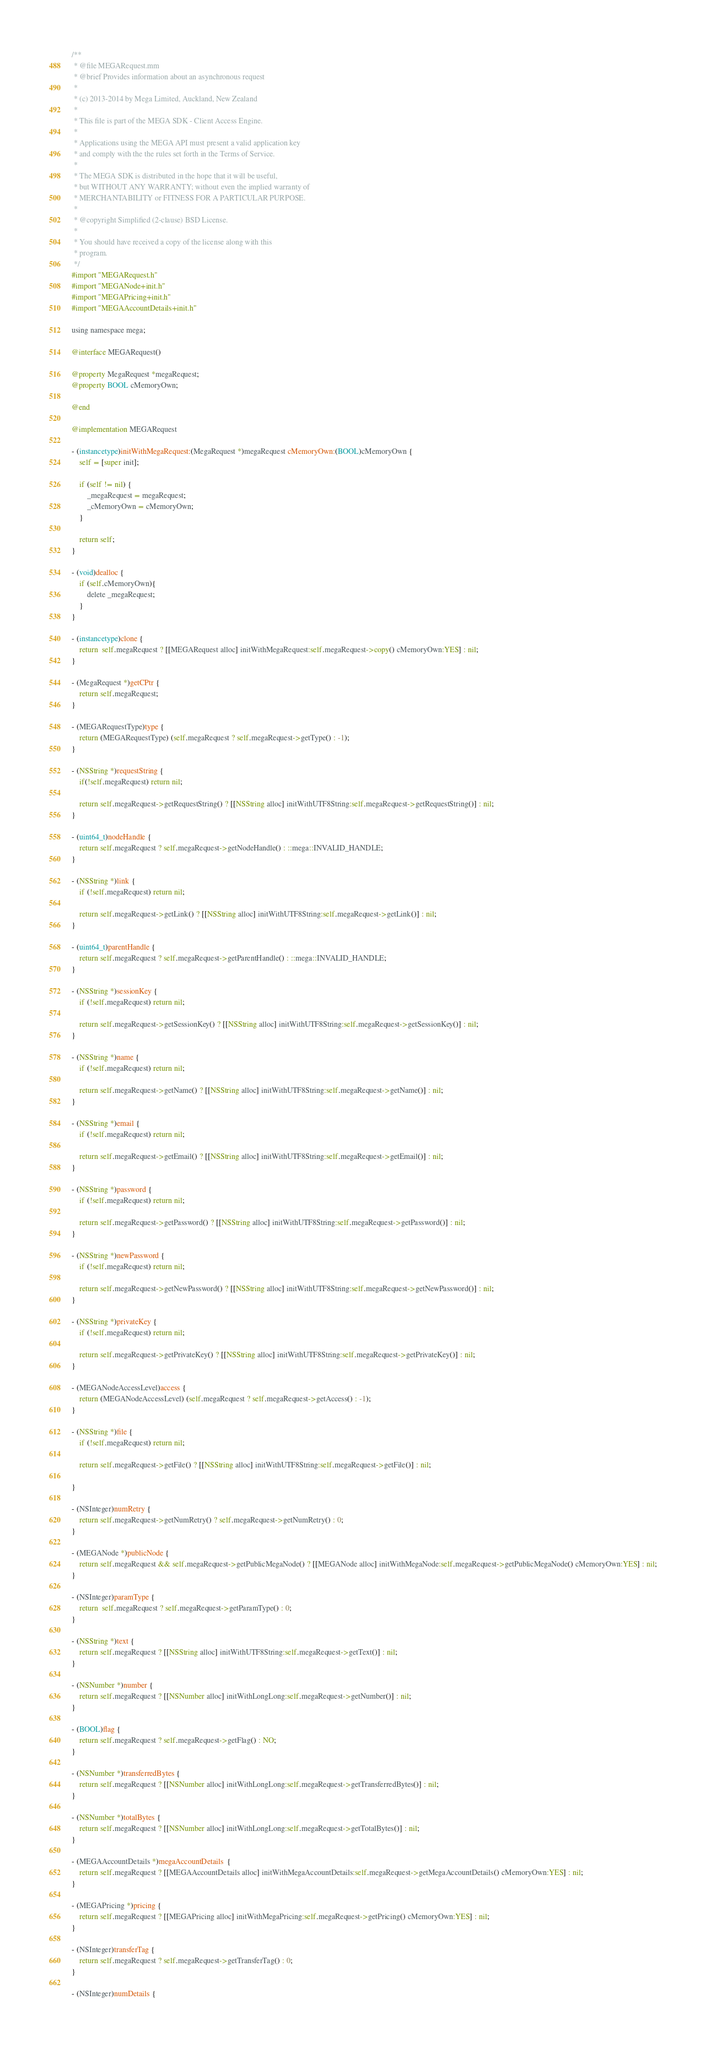Convert code to text. <code><loc_0><loc_0><loc_500><loc_500><_ObjectiveC_>/**
 * @file MEGARequest.mm
 * @brief Provides information about an asynchronous request
 *
 * (c) 2013-2014 by Mega Limited, Auckland, New Zealand
 *
 * This file is part of the MEGA SDK - Client Access Engine.
 *
 * Applications using the MEGA API must present a valid application key
 * and comply with the the rules set forth in the Terms of Service.
 *
 * The MEGA SDK is distributed in the hope that it will be useful,
 * but WITHOUT ANY WARRANTY; without even the implied warranty of
 * MERCHANTABILITY or FITNESS FOR A PARTICULAR PURPOSE.
 *
 * @copyright Simplified (2-clause) BSD License.
 *
 * You should have received a copy of the license along with this
 * program.
 */
#import "MEGARequest.h"
#import "MEGANode+init.h"
#import "MEGAPricing+init.h"
#import "MEGAAccountDetails+init.h"

using namespace mega;

@interface MEGARequest()

@property MegaRequest *megaRequest;
@property BOOL cMemoryOwn;

@end

@implementation MEGARequest

- (instancetype)initWithMegaRequest:(MegaRequest *)megaRequest cMemoryOwn:(BOOL)cMemoryOwn {
    self = [super init];
    
    if (self != nil) {
        _megaRequest = megaRequest;
        _cMemoryOwn = cMemoryOwn;
    }
    
    return self;
}

- (void)dealloc {
    if (self.cMemoryOwn){
        delete _megaRequest;
    }
}

- (instancetype)clone {
    return  self.megaRequest ? [[MEGARequest alloc] initWithMegaRequest:self.megaRequest->copy() cMemoryOwn:YES] : nil;
}

- (MegaRequest *)getCPtr {
    return self.megaRequest;
}

- (MEGARequestType)type {
    return (MEGARequestType) (self.megaRequest ? self.megaRequest->getType() : -1);
}

- (NSString *)requestString {
    if(!self.megaRequest) return nil;
    
    return self.megaRequest->getRequestString() ? [[NSString alloc] initWithUTF8String:self.megaRequest->getRequestString()] : nil;
}

- (uint64_t)nodeHandle {
    return self.megaRequest ? self.megaRequest->getNodeHandle() : ::mega::INVALID_HANDLE;
}

- (NSString *)link {
    if (!self.megaRequest) return nil;
    
    return self.megaRequest->getLink() ? [[NSString alloc] initWithUTF8String:self.megaRequest->getLink()] : nil;
}

- (uint64_t)parentHandle {
    return self.megaRequest ? self.megaRequest->getParentHandle() : ::mega::INVALID_HANDLE;
}

- (NSString *)sessionKey {
    if (!self.megaRequest) return nil;
    
    return self.megaRequest->getSessionKey() ? [[NSString alloc] initWithUTF8String:self.megaRequest->getSessionKey()] : nil;
}

- (NSString *)name {
    if (!self.megaRequest) return nil;
    
    return self.megaRequest->getName() ? [[NSString alloc] initWithUTF8String:self.megaRequest->getName()] : nil;
}

- (NSString *)email {
    if (!self.megaRequest) return nil;
    
    return self.megaRequest->getEmail() ? [[NSString alloc] initWithUTF8String:self.megaRequest->getEmail()] : nil;
}

- (NSString *)password {
    if (!self.megaRequest) return nil;
    
    return self.megaRequest->getPassword() ? [[NSString alloc] initWithUTF8String:self.megaRequest->getPassword()] : nil;
}

- (NSString *)newPassword {
    if (!self.megaRequest) return nil;
    
    return self.megaRequest->getNewPassword() ? [[NSString alloc] initWithUTF8String:self.megaRequest->getNewPassword()] : nil;
}

- (NSString *)privateKey {
    if (!self.megaRequest) return nil;
    
    return self.megaRequest->getPrivateKey() ? [[NSString alloc] initWithUTF8String:self.megaRequest->getPrivateKey()] : nil;
}

- (MEGANodeAccessLevel)access {
    return (MEGANodeAccessLevel) (self.megaRequest ? self.megaRequest->getAccess() : -1);
}

- (NSString *)file {
    if (!self.megaRequest) return nil;
    
    return self.megaRequest->getFile() ? [[NSString alloc] initWithUTF8String:self.megaRequest->getFile()] : nil;
    
}

- (NSInteger)numRetry {
    return self.megaRequest->getNumRetry() ? self.megaRequest->getNumRetry() : 0;
}

- (MEGANode *)publicNode {
    return self.megaRequest && self.megaRequest->getPublicMegaNode() ? [[MEGANode alloc] initWithMegaNode:self.megaRequest->getPublicMegaNode() cMemoryOwn:YES] : nil;
}

- (NSInteger)paramType {
    return  self.megaRequest ? self.megaRequest->getParamType() : 0;
}

- (NSString *)text {
    return self.megaRequest ? [[NSString alloc] initWithUTF8String:self.megaRequest->getText()] : nil;
}

- (NSNumber *)number {
    return self.megaRequest ? [[NSNumber alloc] initWithLongLong:self.megaRequest->getNumber()] : nil;
}

- (BOOL)flag {
    return self.megaRequest ? self.megaRequest->getFlag() : NO;
}

- (NSNumber *)transferredBytes {
    return self.megaRequest ? [[NSNumber alloc] initWithLongLong:self.megaRequest->getTransferredBytes()] : nil;
}

- (NSNumber *)totalBytes {
    return self.megaRequest ? [[NSNumber alloc] initWithLongLong:self.megaRequest->getTotalBytes()] : nil;
}

- (MEGAAccountDetails *)megaAccountDetails  {
    return self.megaRequest ? [[MEGAAccountDetails alloc] initWithMegaAccountDetails:self.megaRequest->getMegaAccountDetails() cMemoryOwn:YES] : nil;
}

- (MEGAPricing *)pricing {
    return self.megaRequest ? [[MEGAPricing alloc] initWithMegaPricing:self.megaRequest->getPricing() cMemoryOwn:YES] : nil;
}

- (NSInteger)transferTag {
    return self.megaRequest ? self.megaRequest->getTransferTag() : 0;
}

- (NSInteger)numDetails {</code> 